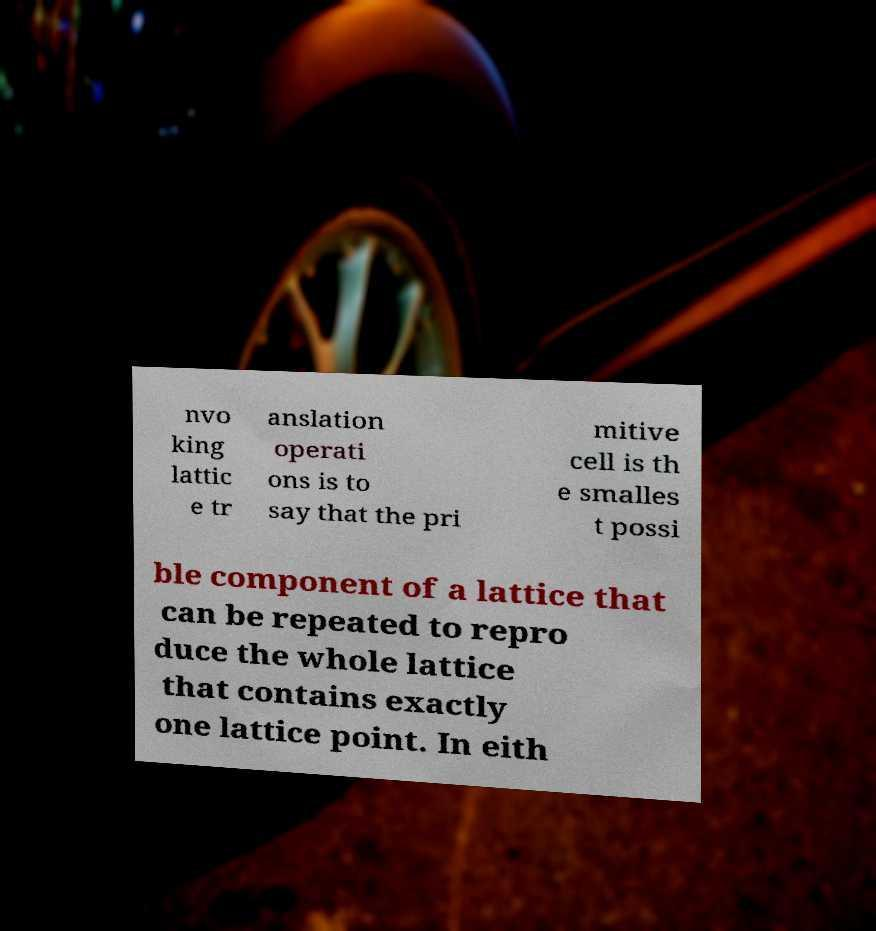Could you assist in decoding the text presented in this image and type it out clearly? nvo king lattic e tr anslation operati ons is to say that the pri mitive cell is th e smalles t possi ble component of a lattice that can be repeated to repro duce the whole lattice that contains exactly one lattice point. In eith 